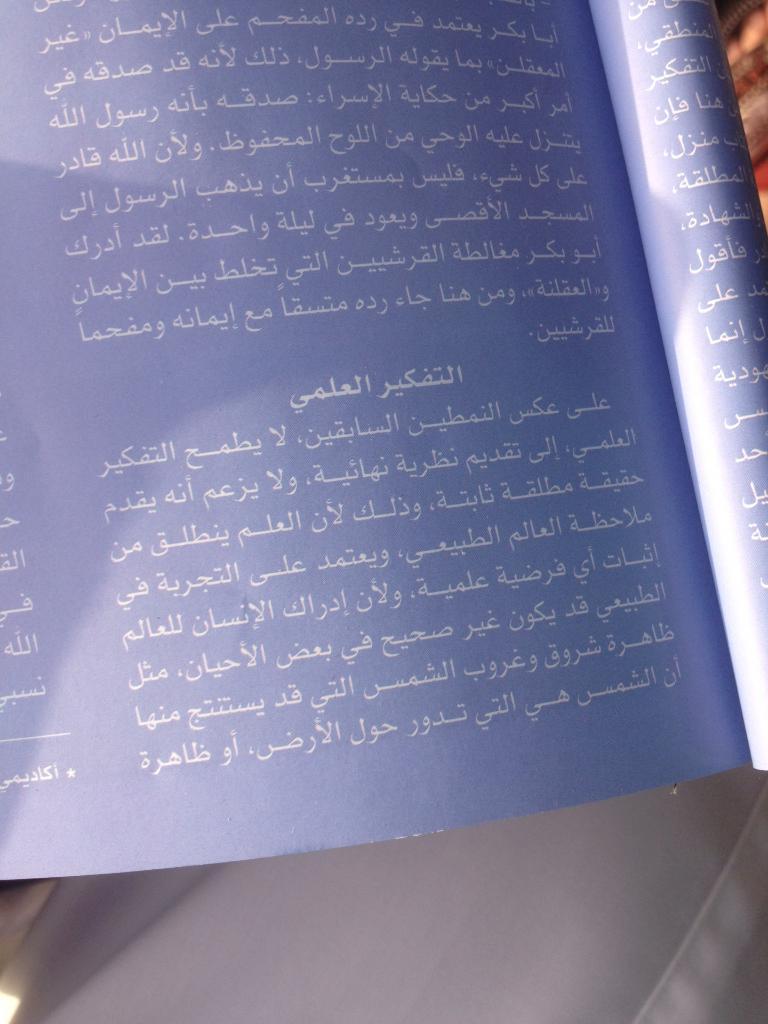Describe this image in one or two sentences. In this picture we can see a book with some text on it and in the background we can see some objects. 